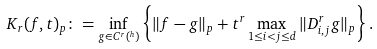Convert formula to latex. <formula><loc_0><loc_0><loc_500><loc_500>K _ { r } ( f , t ) _ { p } \colon = \inf _ { g \in C ^ { r } ( ^ { h } ) } \left \{ \| f - g \| _ { p } + t ^ { r } \max _ { 1 \leq i < j \leq d } \| D _ { i , j } ^ { r } g \| _ { p } \right \} .</formula> 